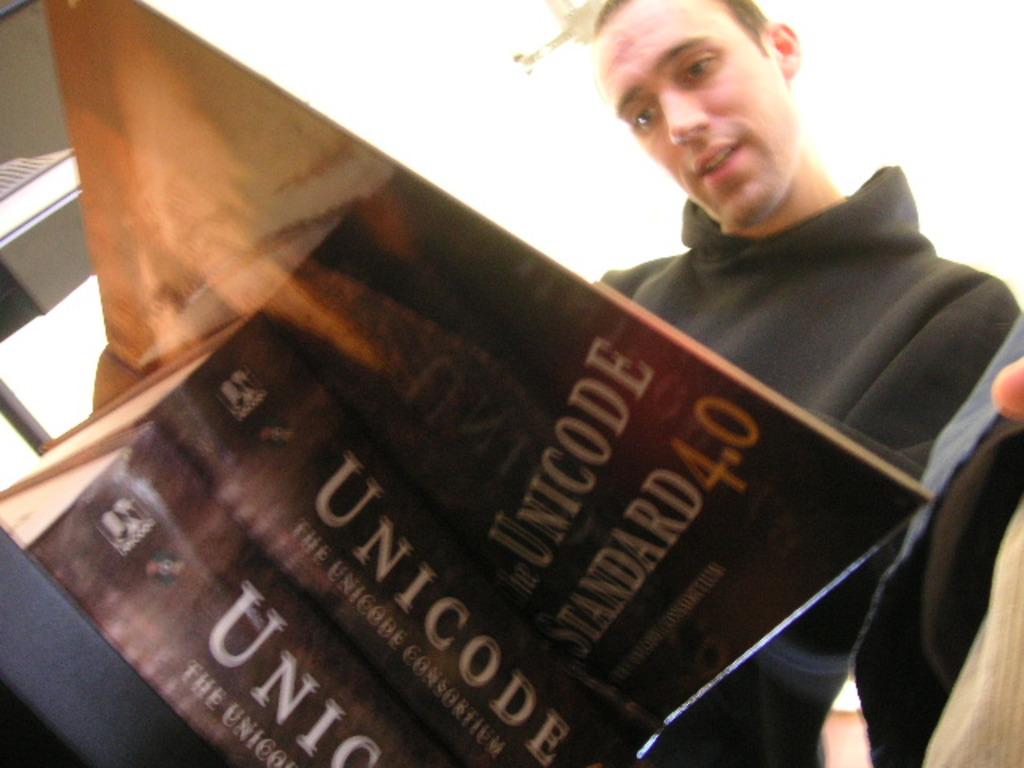What edition is this book?
Offer a terse response. 4.0. 